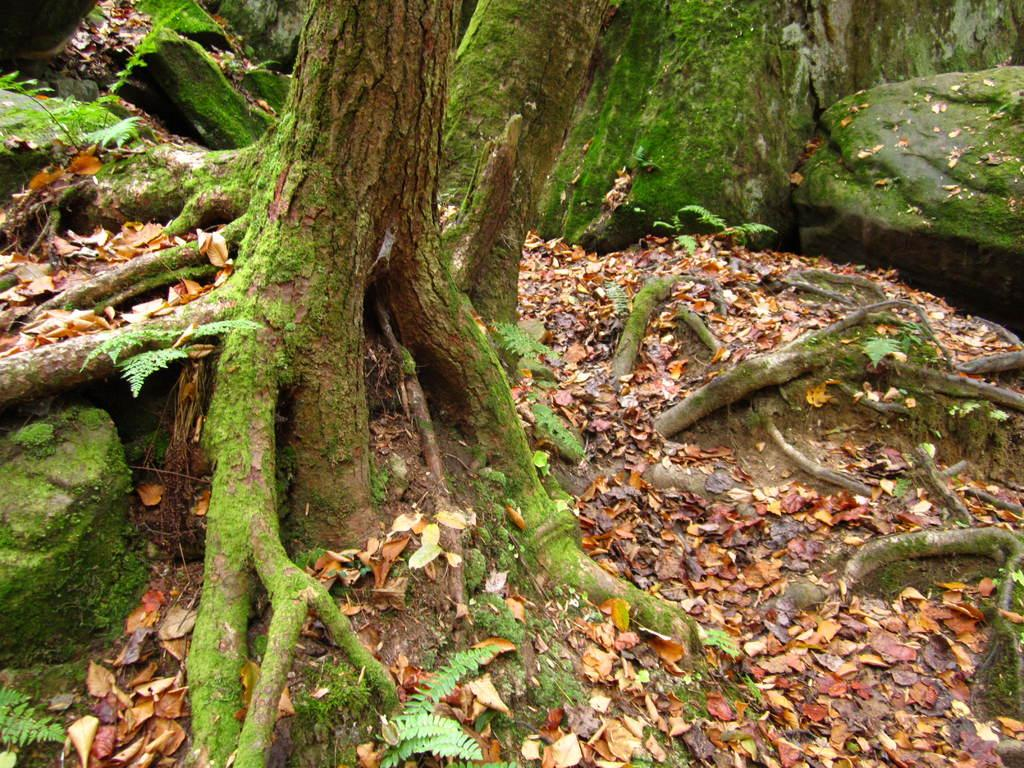Where was the image taken? The image was taken from a forest. What can be seen in the image besides the forest? There are trees, rocks, and a land area visible in the image. What is present in the land area? There are leaves and plants in the land area. What type of toys can be seen in the image? There are no toys present in the image. What animal can be seen interacting with the plants in the land area? There is no animal visible in the image; it only features trees, rocks, and the land area with leaves and plants. 